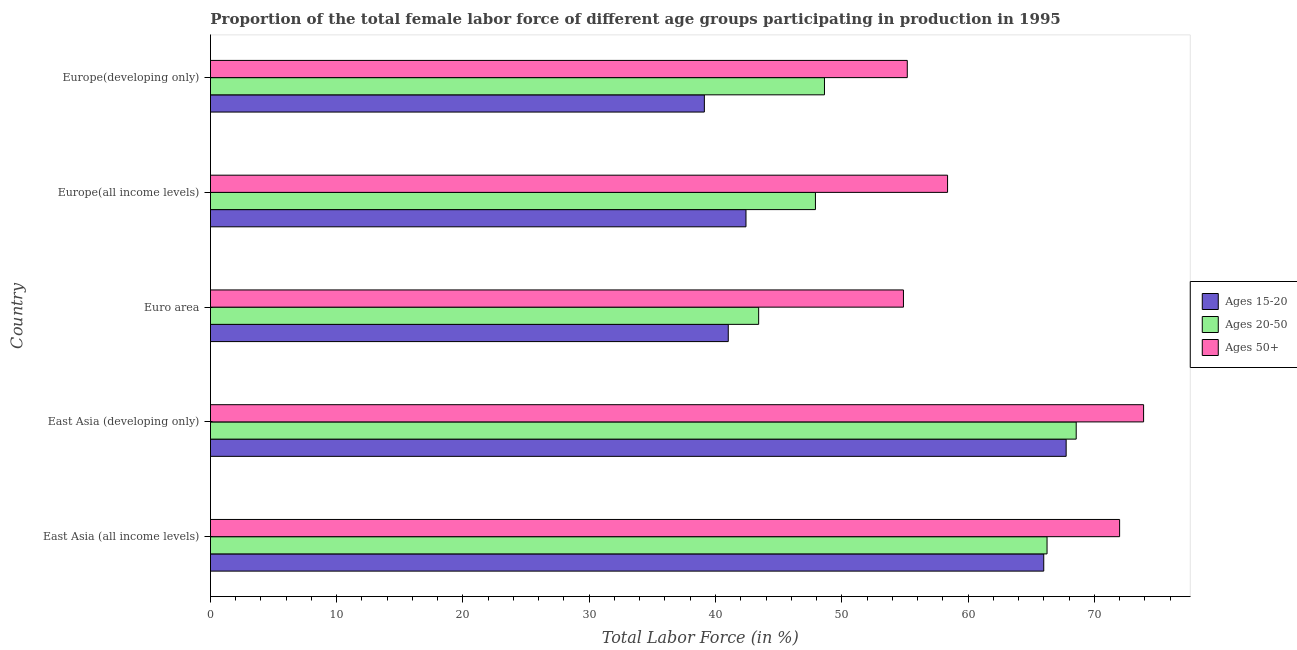How many different coloured bars are there?
Make the answer very short. 3. Are the number of bars per tick equal to the number of legend labels?
Ensure brevity in your answer.  Yes. Are the number of bars on each tick of the Y-axis equal?
Provide a succinct answer. Yes. How many bars are there on the 1st tick from the top?
Offer a terse response. 3. How many bars are there on the 1st tick from the bottom?
Your answer should be compact. 3. What is the label of the 4th group of bars from the top?
Provide a succinct answer. East Asia (developing only). In how many cases, is the number of bars for a given country not equal to the number of legend labels?
Make the answer very short. 0. What is the percentage of female labor force within the age group 15-20 in Euro area?
Keep it short and to the point. 41.01. Across all countries, what is the maximum percentage of female labor force above age 50?
Give a very brief answer. 73.91. Across all countries, what is the minimum percentage of female labor force within the age group 15-20?
Make the answer very short. 39.12. In which country was the percentage of female labor force within the age group 15-20 maximum?
Give a very brief answer. East Asia (developing only). What is the total percentage of female labor force within the age group 20-50 in the graph?
Your response must be concise. 274.8. What is the difference between the percentage of female labor force within the age group 15-20 in Euro area and that in Europe(developing only)?
Ensure brevity in your answer.  1.89. What is the difference between the percentage of female labor force within the age group 15-20 in Europe(all income levels) and the percentage of female labor force above age 50 in East Asia (developing only)?
Make the answer very short. -31.49. What is the average percentage of female labor force above age 50 per country?
Your answer should be very brief. 62.88. What is the difference between the percentage of female labor force above age 50 and percentage of female labor force within the age group 20-50 in East Asia (all income levels)?
Offer a very short reply. 5.75. What is the difference between the highest and the second highest percentage of female labor force above age 50?
Keep it short and to the point. 1.9. What is the difference between the highest and the lowest percentage of female labor force within the age group 15-20?
Your answer should be compact. 28.66. Is the sum of the percentage of female labor force within the age group 20-50 in Euro area and Europe(all income levels) greater than the maximum percentage of female labor force within the age group 15-20 across all countries?
Offer a very short reply. Yes. What does the 2nd bar from the top in Europe(developing only) represents?
Your answer should be very brief. Ages 20-50. What does the 1st bar from the bottom in East Asia (all income levels) represents?
Provide a succinct answer. Ages 15-20. Is it the case that in every country, the sum of the percentage of female labor force within the age group 15-20 and percentage of female labor force within the age group 20-50 is greater than the percentage of female labor force above age 50?
Your answer should be compact. Yes. How many bars are there?
Provide a succinct answer. 15. What is the difference between two consecutive major ticks on the X-axis?
Offer a terse response. 10. Are the values on the major ticks of X-axis written in scientific E-notation?
Provide a succinct answer. No. Does the graph contain any zero values?
Your answer should be compact. No. Does the graph contain grids?
Offer a terse response. No. How are the legend labels stacked?
Give a very brief answer. Vertical. What is the title of the graph?
Provide a short and direct response. Proportion of the total female labor force of different age groups participating in production in 1995. What is the label or title of the Y-axis?
Keep it short and to the point. Country. What is the Total Labor Force (in %) in Ages 15-20 in East Asia (all income levels)?
Provide a short and direct response. 66. What is the Total Labor Force (in %) of Ages 20-50 in East Asia (all income levels)?
Provide a succinct answer. 66.26. What is the Total Labor Force (in %) of Ages 50+ in East Asia (all income levels)?
Provide a succinct answer. 72.01. What is the Total Labor Force (in %) of Ages 15-20 in East Asia (developing only)?
Your answer should be compact. 67.77. What is the Total Labor Force (in %) of Ages 20-50 in East Asia (developing only)?
Offer a very short reply. 68.57. What is the Total Labor Force (in %) in Ages 50+ in East Asia (developing only)?
Offer a terse response. 73.91. What is the Total Labor Force (in %) of Ages 15-20 in Euro area?
Give a very brief answer. 41.01. What is the Total Labor Force (in %) of Ages 20-50 in Euro area?
Keep it short and to the point. 43.42. What is the Total Labor Force (in %) in Ages 50+ in Euro area?
Keep it short and to the point. 54.89. What is the Total Labor Force (in %) in Ages 15-20 in Europe(all income levels)?
Make the answer very short. 42.41. What is the Total Labor Force (in %) of Ages 20-50 in Europe(all income levels)?
Your response must be concise. 47.92. What is the Total Labor Force (in %) of Ages 50+ in Europe(all income levels)?
Your answer should be compact. 58.38. What is the Total Labor Force (in %) in Ages 15-20 in Europe(developing only)?
Provide a succinct answer. 39.12. What is the Total Labor Force (in %) of Ages 20-50 in Europe(developing only)?
Your response must be concise. 48.63. What is the Total Labor Force (in %) of Ages 50+ in Europe(developing only)?
Keep it short and to the point. 55.19. Across all countries, what is the maximum Total Labor Force (in %) in Ages 15-20?
Your answer should be very brief. 67.77. Across all countries, what is the maximum Total Labor Force (in %) of Ages 20-50?
Offer a terse response. 68.57. Across all countries, what is the maximum Total Labor Force (in %) of Ages 50+?
Offer a terse response. 73.91. Across all countries, what is the minimum Total Labor Force (in %) in Ages 15-20?
Offer a terse response. 39.12. Across all countries, what is the minimum Total Labor Force (in %) of Ages 20-50?
Offer a very short reply. 43.42. Across all countries, what is the minimum Total Labor Force (in %) in Ages 50+?
Your response must be concise. 54.89. What is the total Total Labor Force (in %) of Ages 15-20 in the graph?
Ensure brevity in your answer.  256.32. What is the total Total Labor Force (in %) in Ages 20-50 in the graph?
Provide a succinct answer. 274.8. What is the total Total Labor Force (in %) of Ages 50+ in the graph?
Give a very brief answer. 314.38. What is the difference between the Total Labor Force (in %) of Ages 15-20 in East Asia (all income levels) and that in East Asia (developing only)?
Your answer should be compact. -1.77. What is the difference between the Total Labor Force (in %) of Ages 20-50 in East Asia (all income levels) and that in East Asia (developing only)?
Make the answer very short. -2.31. What is the difference between the Total Labor Force (in %) of Ages 50+ in East Asia (all income levels) and that in East Asia (developing only)?
Your answer should be very brief. -1.9. What is the difference between the Total Labor Force (in %) of Ages 15-20 in East Asia (all income levels) and that in Euro area?
Offer a terse response. 24.99. What is the difference between the Total Labor Force (in %) in Ages 20-50 in East Asia (all income levels) and that in Euro area?
Offer a terse response. 22.84. What is the difference between the Total Labor Force (in %) of Ages 50+ in East Asia (all income levels) and that in Euro area?
Offer a very short reply. 17.12. What is the difference between the Total Labor Force (in %) of Ages 15-20 in East Asia (all income levels) and that in Europe(all income levels)?
Offer a very short reply. 23.58. What is the difference between the Total Labor Force (in %) in Ages 20-50 in East Asia (all income levels) and that in Europe(all income levels)?
Your response must be concise. 18.34. What is the difference between the Total Labor Force (in %) in Ages 50+ in East Asia (all income levels) and that in Europe(all income levels)?
Your answer should be compact. 13.63. What is the difference between the Total Labor Force (in %) in Ages 15-20 in East Asia (all income levels) and that in Europe(developing only)?
Offer a very short reply. 26.88. What is the difference between the Total Labor Force (in %) of Ages 20-50 in East Asia (all income levels) and that in Europe(developing only)?
Your answer should be very brief. 17.63. What is the difference between the Total Labor Force (in %) of Ages 50+ in East Asia (all income levels) and that in Europe(developing only)?
Your answer should be very brief. 16.82. What is the difference between the Total Labor Force (in %) in Ages 15-20 in East Asia (developing only) and that in Euro area?
Keep it short and to the point. 26.76. What is the difference between the Total Labor Force (in %) in Ages 20-50 in East Asia (developing only) and that in Euro area?
Provide a short and direct response. 25.15. What is the difference between the Total Labor Force (in %) in Ages 50+ in East Asia (developing only) and that in Euro area?
Provide a succinct answer. 19.02. What is the difference between the Total Labor Force (in %) in Ages 15-20 in East Asia (developing only) and that in Europe(all income levels)?
Your answer should be very brief. 25.36. What is the difference between the Total Labor Force (in %) in Ages 20-50 in East Asia (developing only) and that in Europe(all income levels)?
Provide a succinct answer. 20.65. What is the difference between the Total Labor Force (in %) of Ages 50+ in East Asia (developing only) and that in Europe(all income levels)?
Make the answer very short. 15.53. What is the difference between the Total Labor Force (in %) of Ages 15-20 in East Asia (developing only) and that in Europe(developing only)?
Provide a succinct answer. 28.66. What is the difference between the Total Labor Force (in %) of Ages 20-50 in East Asia (developing only) and that in Europe(developing only)?
Give a very brief answer. 19.94. What is the difference between the Total Labor Force (in %) in Ages 50+ in East Asia (developing only) and that in Europe(developing only)?
Provide a short and direct response. 18.72. What is the difference between the Total Labor Force (in %) in Ages 15-20 in Euro area and that in Europe(all income levels)?
Offer a very short reply. -1.4. What is the difference between the Total Labor Force (in %) of Ages 20-50 in Euro area and that in Europe(all income levels)?
Provide a short and direct response. -4.5. What is the difference between the Total Labor Force (in %) of Ages 50+ in Euro area and that in Europe(all income levels)?
Ensure brevity in your answer.  -3.49. What is the difference between the Total Labor Force (in %) in Ages 15-20 in Euro area and that in Europe(developing only)?
Ensure brevity in your answer.  1.89. What is the difference between the Total Labor Force (in %) in Ages 20-50 in Euro area and that in Europe(developing only)?
Offer a very short reply. -5.21. What is the difference between the Total Labor Force (in %) in Ages 50+ in Euro area and that in Europe(developing only)?
Ensure brevity in your answer.  -0.3. What is the difference between the Total Labor Force (in %) of Ages 15-20 in Europe(all income levels) and that in Europe(developing only)?
Your response must be concise. 3.3. What is the difference between the Total Labor Force (in %) of Ages 20-50 in Europe(all income levels) and that in Europe(developing only)?
Offer a terse response. -0.72. What is the difference between the Total Labor Force (in %) in Ages 50+ in Europe(all income levels) and that in Europe(developing only)?
Your response must be concise. 3.19. What is the difference between the Total Labor Force (in %) of Ages 15-20 in East Asia (all income levels) and the Total Labor Force (in %) of Ages 20-50 in East Asia (developing only)?
Provide a short and direct response. -2.57. What is the difference between the Total Labor Force (in %) in Ages 15-20 in East Asia (all income levels) and the Total Labor Force (in %) in Ages 50+ in East Asia (developing only)?
Your response must be concise. -7.91. What is the difference between the Total Labor Force (in %) in Ages 20-50 in East Asia (all income levels) and the Total Labor Force (in %) in Ages 50+ in East Asia (developing only)?
Make the answer very short. -7.65. What is the difference between the Total Labor Force (in %) of Ages 15-20 in East Asia (all income levels) and the Total Labor Force (in %) of Ages 20-50 in Euro area?
Your answer should be compact. 22.58. What is the difference between the Total Labor Force (in %) of Ages 15-20 in East Asia (all income levels) and the Total Labor Force (in %) of Ages 50+ in Euro area?
Offer a terse response. 11.11. What is the difference between the Total Labor Force (in %) in Ages 20-50 in East Asia (all income levels) and the Total Labor Force (in %) in Ages 50+ in Euro area?
Your response must be concise. 11.37. What is the difference between the Total Labor Force (in %) of Ages 15-20 in East Asia (all income levels) and the Total Labor Force (in %) of Ages 20-50 in Europe(all income levels)?
Your answer should be very brief. 18.08. What is the difference between the Total Labor Force (in %) of Ages 15-20 in East Asia (all income levels) and the Total Labor Force (in %) of Ages 50+ in Europe(all income levels)?
Keep it short and to the point. 7.62. What is the difference between the Total Labor Force (in %) in Ages 20-50 in East Asia (all income levels) and the Total Labor Force (in %) in Ages 50+ in Europe(all income levels)?
Provide a succinct answer. 7.88. What is the difference between the Total Labor Force (in %) in Ages 15-20 in East Asia (all income levels) and the Total Labor Force (in %) in Ages 20-50 in Europe(developing only)?
Your response must be concise. 17.37. What is the difference between the Total Labor Force (in %) in Ages 15-20 in East Asia (all income levels) and the Total Labor Force (in %) in Ages 50+ in Europe(developing only)?
Ensure brevity in your answer.  10.81. What is the difference between the Total Labor Force (in %) of Ages 20-50 in East Asia (all income levels) and the Total Labor Force (in %) of Ages 50+ in Europe(developing only)?
Your response must be concise. 11.07. What is the difference between the Total Labor Force (in %) of Ages 15-20 in East Asia (developing only) and the Total Labor Force (in %) of Ages 20-50 in Euro area?
Provide a short and direct response. 24.35. What is the difference between the Total Labor Force (in %) in Ages 15-20 in East Asia (developing only) and the Total Labor Force (in %) in Ages 50+ in Euro area?
Offer a terse response. 12.89. What is the difference between the Total Labor Force (in %) of Ages 20-50 in East Asia (developing only) and the Total Labor Force (in %) of Ages 50+ in Euro area?
Make the answer very short. 13.68. What is the difference between the Total Labor Force (in %) of Ages 15-20 in East Asia (developing only) and the Total Labor Force (in %) of Ages 20-50 in Europe(all income levels)?
Keep it short and to the point. 19.86. What is the difference between the Total Labor Force (in %) in Ages 15-20 in East Asia (developing only) and the Total Labor Force (in %) in Ages 50+ in Europe(all income levels)?
Offer a very short reply. 9.39. What is the difference between the Total Labor Force (in %) of Ages 20-50 in East Asia (developing only) and the Total Labor Force (in %) of Ages 50+ in Europe(all income levels)?
Make the answer very short. 10.19. What is the difference between the Total Labor Force (in %) of Ages 15-20 in East Asia (developing only) and the Total Labor Force (in %) of Ages 20-50 in Europe(developing only)?
Provide a short and direct response. 19.14. What is the difference between the Total Labor Force (in %) in Ages 15-20 in East Asia (developing only) and the Total Labor Force (in %) in Ages 50+ in Europe(developing only)?
Offer a very short reply. 12.58. What is the difference between the Total Labor Force (in %) in Ages 20-50 in East Asia (developing only) and the Total Labor Force (in %) in Ages 50+ in Europe(developing only)?
Ensure brevity in your answer.  13.38. What is the difference between the Total Labor Force (in %) of Ages 15-20 in Euro area and the Total Labor Force (in %) of Ages 20-50 in Europe(all income levels)?
Provide a short and direct response. -6.9. What is the difference between the Total Labor Force (in %) in Ages 15-20 in Euro area and the Total Labor Force (in %) in Ages 50+ in Europe(all income levels)?
Offer a terse response. -17.37. What is the difference between the Total Labor Force (in %) of Ages 20-50 in Euro area and the Total Labor Force (in %) of Ages 50+ in Europe(all income levels)?
Your answer should be very brief. -14.96. What is the difference between the Total Labor Force (in %) in Ages 15-20 in Euro area and the Total Labor Force (in %) in Ages 20-50 in Europe(developing only)?
Offer a very short reply. -7.62. What is the difference between the Total Labor Force (in %) of Ages 15-20 in Euro area and the Total Labor Force (in %) of Ages 50+ in Europe(developing only)?
Your response must be concise. -14.18. What is the difference between the Total Labor Force (in %) in Ages 20-50 in Euro area and the Total Labor Force (in %) in Ages 50+ in Europe(developing only)?
Offer a very short reply. -11.77. What is the difference between the Total Labor Force (in %) in Ages 15-20 in Europe(all income levels) and the Total Labor Force (in %) in Ages 20-50 in Europe(developing only)?
Ensure brevity in your answer.  -6.22. What is the difference between the Total Labor Force (in %) of Ages 15-20 in Europe(all income levels) and the Total Labor Force (in %) of Ages 50+ in Europe(developing only)?
Offer a very short reply. -12.78. What is the difference between the Total Labor Force (in %) of Ages 20-50 in Europe(all income levels) and the Total Labor Force (in %) of Ages 50+ in Europe(developing only)?
Offer a very short reply. -7.28. What is the average Total Labor Force (in %) of Ages 15-20 per country?
Provide a short and direct response. 51.26. What is the average Total Labor Force (in %) in Ages 20-50 per country?
Offer a terse response. 54.96. What is the average Total Labor Force (in %) of Ages 50+ per country?
Offer a terse response. 62.88. What is the difference between the Total Labor Force (in %) of Ages 15-20 and Total Labor Force (in %) of Ages 20-50 in East Asia (all income levels)?
Provide a short and direct response. -0.26. What is the difference between the Total Labor Force (in %) of Ages 15-20 and Total Labor Force (in %) of Ages 50+ in East Asia (all income levels)?
Make the answer very short. -6.01. What is the difference between the Total Labor Force (in %) of Ages 20-50 and Total Labor Force (in %) of Ages 50+ in East Asia (all income levels)?
Provide a succinct answer. -5.75. What is the difference between the Total Labor Force (in %) in Ages 15-20 and Total Labor Force (in %) in Ages 20-50 in East Asia (developing only)?
Keep it short and to the point. -0.8. What is the difference between the Total Labor Force (in %) of Ages 15-20 and Total Labor Force (in %) of Ages 50+ in East Asia (developing only)?
Give a very brief answer. -6.13. What is the difference between the Total Labor Force (in %) in Ages 20-50 and Total Labor Force (in %) in Ages 50+ in East Asia (developing only)?
Give a very brief answer. -5.34. What is the difference between the Total Labor Force (in %) in Ages 15-20 and Total Labor Force (in %) in Ages 20-50 in Euro area?
Make the answer very short. -2.41. What is the difference between the Total Labor Force (in %) in Ages 15-20 and Total Labor Force (in %) in Ages 50+ in Euro area?
Your response must be concise. -13.88. What is the difference between the Total Labor Force (in %) of Ages 20-50 and Total Labor Force (in %) of Ages 50+ in Euro area?
Your response must be concise. -11.47. What is the difference between the Total Labor Force (in %) of Ages 15-20 and Total Labor Force (in %) of Ages 20-50 in Europe(all income levels)?
Offer a very short reply. -5.5. What is the difference between the Total Labor Force (in %) of Ages 15-20 and Total Labor Force (in %) of Ages 50+ in Europe(all income levels)?
Make the answer very short. -15.97. What is the difference between the Total Labor Force (in %) of Ages 20-50 and Total Labor Force (in %) of Ages 50+ in Europe(all income levels)?
Offer a very short reply. -10.47. What is the difference between the Total Labor Force (in %) in Ages 15-20 and Total Labor Force (in %) in Ages 20-50 in Europe(developing only)?
Your answer should be very brief. -9.51. What is the difference between the Total Labor Force (in %) in Ages 15-20 and Total Labor Force (in %) in Ages 50+ in Europe(developing only)?
Offer a very short reply. -16.07. What is the difference between the Total Labor Force (in %) in Ages 20-50 and Total Labor Force (in %) in Ages 50+ in Europe(developing only)?
Your answer should be very brief. -6.56. What is the ratio of the Total Labor Force (in %) of Ages 15-20 in East Asia (all income levels) to that in East Asia (developing only)?
Offer a terse response. 0.97. What is the ratio of the Total Labor Force (in %) of Ages 20-50 in East Asia (all income levels) to that in East Asia (developing only)?
Keep it short and to the point. 0.97. What is the ratio of the Total Labor Force (in %) of Ages 50+ in East Asia (all income levels) to that in East Asia (developing only)?
Make the answer very short. 0.97. What is the ratio of the Total Labor Force (in %) in Ages 15-20 in East Asia (all income levels) to that in Euro area?
Provide a short and direct response. 1.61. What is the ratio of the Total Labor Force (in %) in Ages 20-50 in East Asia (all income levels) to that in Euro area?
Provide a succinct answer. 1.53. What is the ratio of the Total Labor Force (in %) of Ages 50+ in East Asia (all income levels) to that in Euro area?
Give a very brief answer. 1.31. What is the ratio of the Total Labor Force (in %) of Ages 15-20 in East Asia (all income levels) to that in Europe(all income levels)?
Your response must be concise. 1.56. What is the ratio of the Total Labor Force (in %) in Ages 20-50 in East Asia (all income levels) to that in Europe(all income levels)?
Your answer should be very brief. 1.38. What is the ratio of the Total Labor Force (in %) in Ages 50+ in East Asia (all income levels) to that in Europe(all income levels)?
Ensure brevity in your answer.  1.23. What is the ratio of the Total Labor Force (in %) of Ages 15-20 in East Asia (all income levels) to that in Europe(developing only)?
Ensure brevity in your answer.  1.69. What is the ratio of the Total Labor Force (in %) in Ages 20-50 in East Asia (all income levels) to that in Europe(developing only)?
Your answer should be very brief. 1.36. What is the ratio of the Total Labor Force (in %) of Ages 50+ in East Asia (all income levels) to that in Europe(developing only)?
Provide a succinct answer. 1.3. What is the ratio of the Total Labor Force (in %) of Ages 15-20 in East Asia (developing only) to that in Euro area?
Your answer should be very brief. 1.65. What is the ratio of the Total Labor Force (in %) in Ages 20-50 in East Asia (developing only) to that in Euro area?
Give a very brief answer. 1.58. What is the ratio of the Total Labor Force (in %) of Ages 50+ in East Asia (developing only) to that in Euro area?
Your response must be concise. 1.35. What is the ratio of the Total Labor Force (in %) in Ages 15-20 in East Asia (developing only) to that in Europe(all income levels)?
Offer a very short reply. 1.6. What is the ratio of the Total Labor Force (in %) in Ages 20-50 in East Asia (developing only) to that in Europe(all income levels)?
Your answer should be compact. 1.43. What is the ratio of the Total Labor Force (in %) of Ages 50+ in East Asia (developing only) to that in Europe(all income levels)?
Offer a terse response. 1.27. What is the ratio of the Total Labor Force (in %) in Ages 15-20 in East Asia (developing only) to that in Europe(developing only)?
Your answer should be very brief. 1.73. What is the ratio of the Total Labor Force (in %) in Ages 20-50 in East Asia (developing only) to that in Europe(developing only)?
Ensure brevity in your answer.  1.41. What is the ratio of the Total Labor Force (in %) in Ages 50+ in East Asia (developing only) to that in Europe(developing only)?
Ensure brevity in your answer.  1.34. What is the ratio of the Total Labor Force (in %) of Ages 15-20 in Euro area to that in Europe(all income levels)?
Give a very brief answer. 0.97. What is the ratio of the Total Labor Force (in %) in Ages 20-50 in Euro area to that in Europe(all income levels)?
Give a very brief answer. 0.91. What is the ratio of the Total Labor Force (in %) of Ages 50+ in Euro area to that in Europe(all income levels)?
Make the answer very short. 0.94. What is the ratio of the Total Labor Force (in %) in Ages 15-20 in Euro area to that in Europe(developing only)?
Provide a short and direct response. 1.05. What is the ratio of the Total Labor Force (in %) in Ages 20-50 in Euro area to that in Europe(developing only)?
Your response must be concise. 0.89. What is the ratio of the Total Labor Force (in %) of Ages 15-20 in Europe(all income levels) to that in Europe(developing only)?
Make the answer very short. 1.08. What is the ratio of the Total Labor Force (in %) in Ages 50+ in Europe(all income levels) to that in Europe(developing only)?
Give a very brief answer. 1.06. What is the difference between the highest and the second highest Total Labor Force (in %) of Ages 15-20?
Provide a succinct answer. 1.77. What is the difference between the highest and the second highest Total Labor Force (in %) of Ages 20-50?
Offer a terse response. 2.31. What is the difference between the highest and the second highest Total Labor Force (in %) of Ages 50+?
Your response must be concise. 1.9. What is the difference between the highest and the lowest Total Labor Force (in %) of Ages 15-20?
Provide a short and direct response. 28.66. What is the difference between the highest and the lowest Total Labor Force (in %) in Ages 20-50?
Offer a terse response. 25.15. What is the difference between the highest and the lowest Total Labor Force (in %) in Ages 50+?
Your answer should be compact. 19.02. 